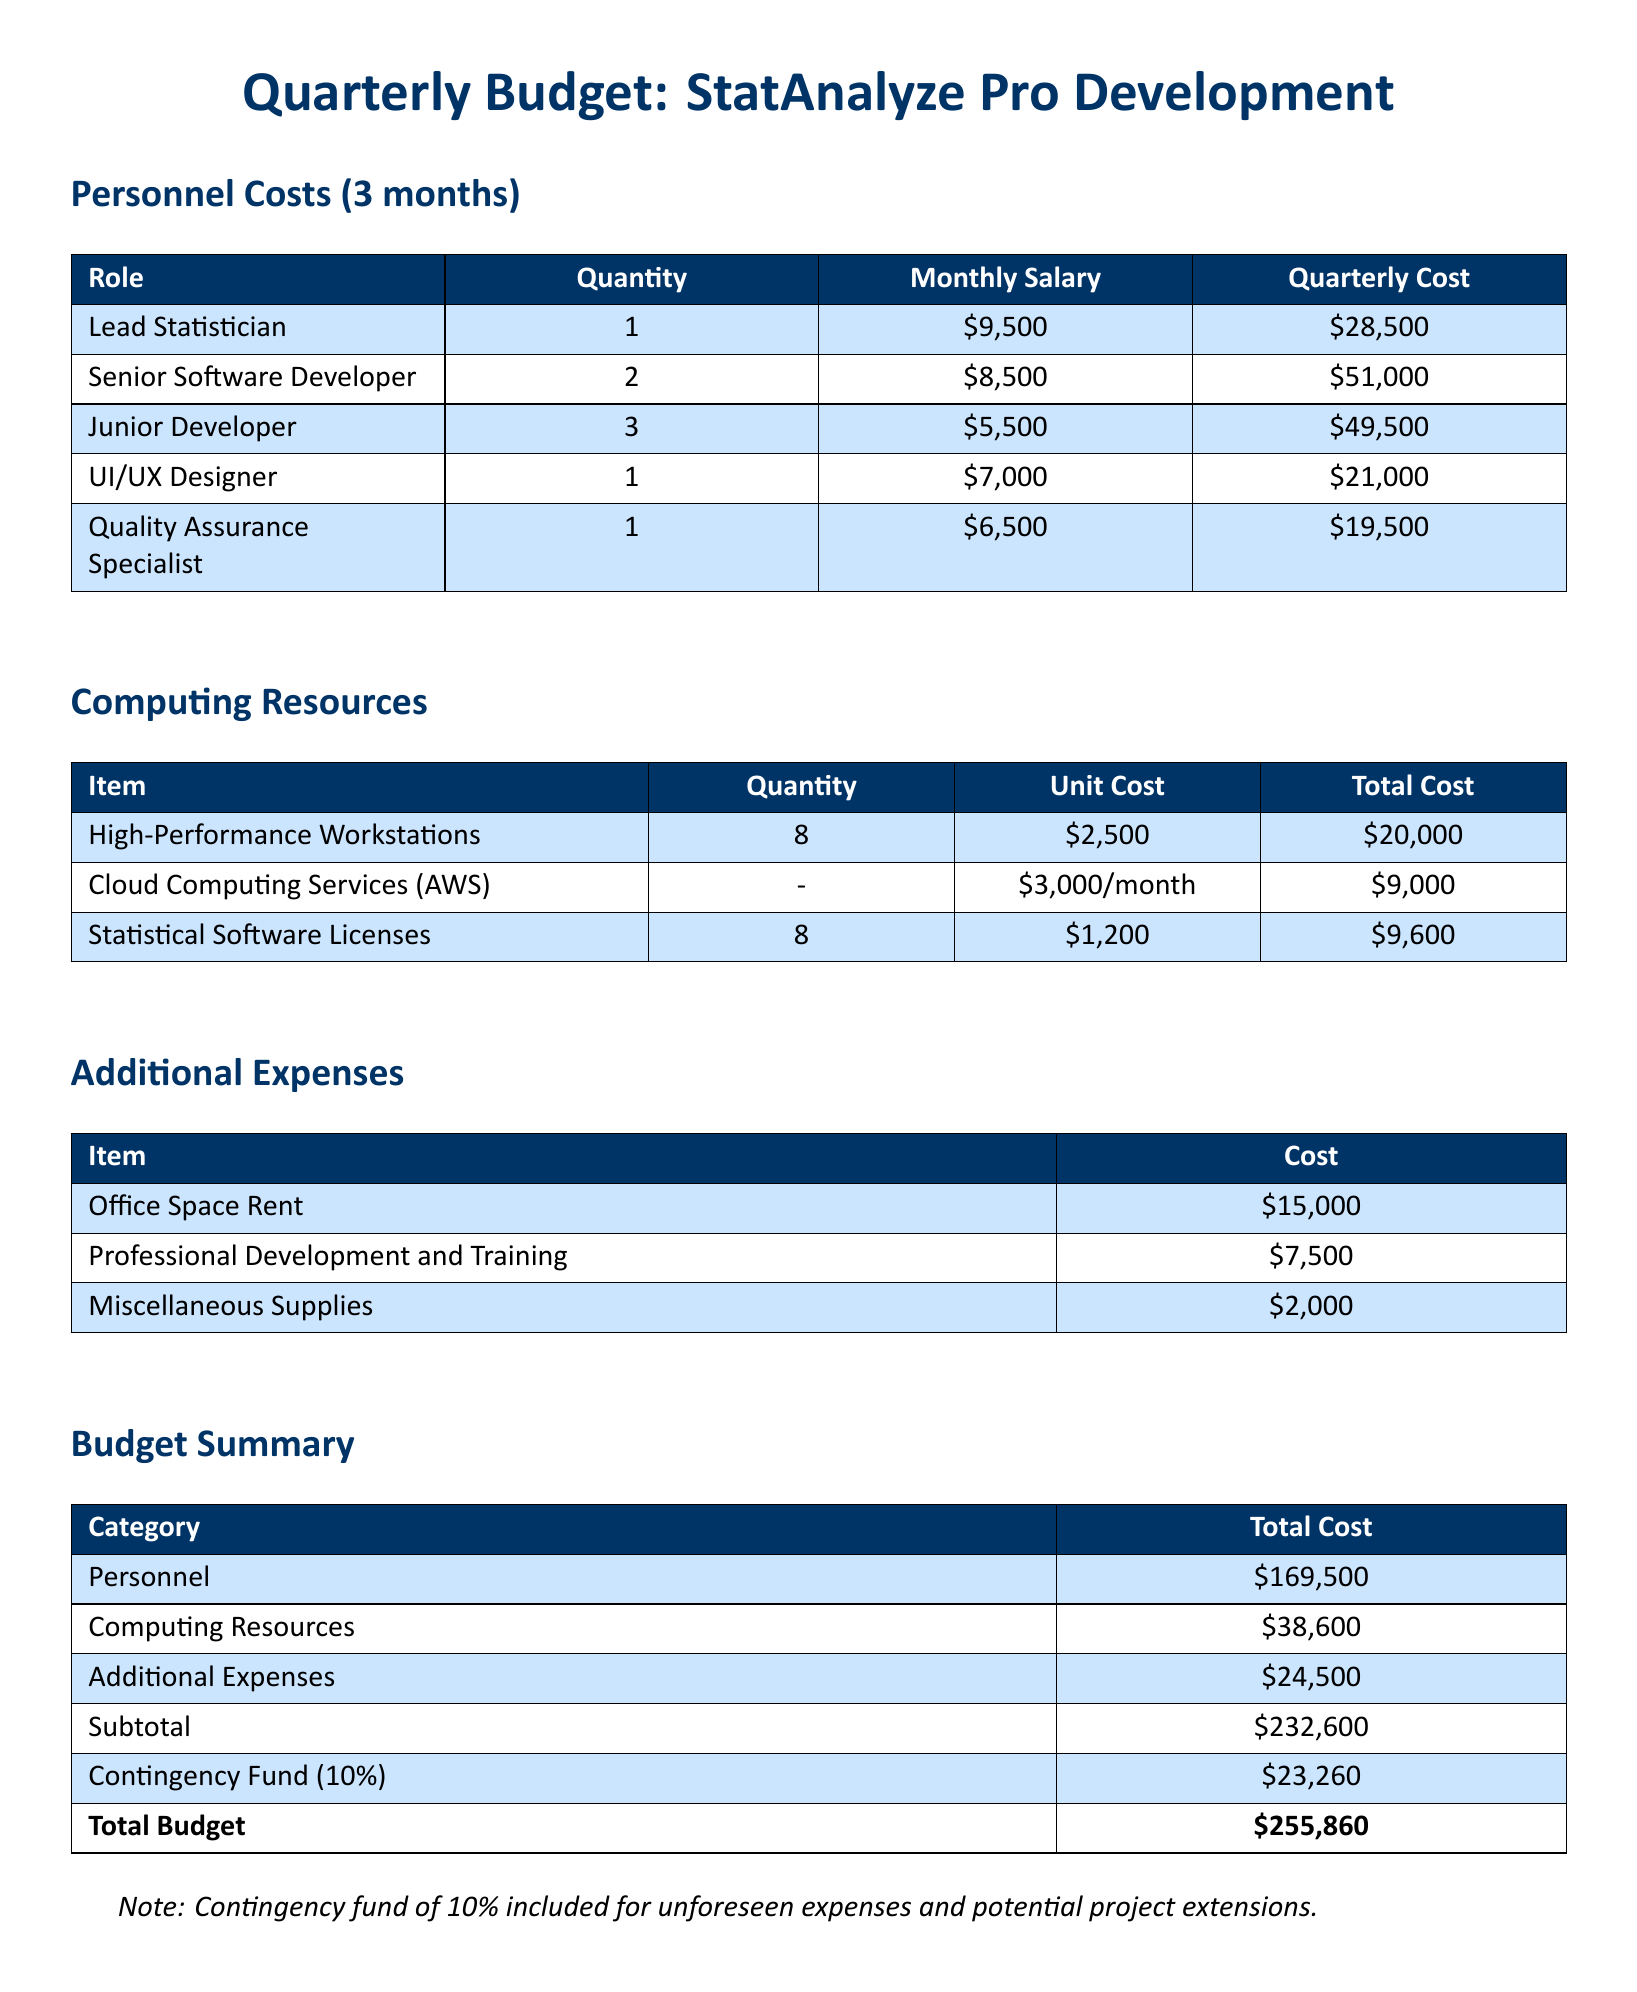What is the total personnel cost for three months? The total personnel cost is the sum of all individual roles' quarterly costs: 28500 + 51000 + 49500 + 21000 + 19500 = 169500.
Answer: 169500 How many junior developers are included in the budget? The budget specifies there are 3 junior developers listed under personnel costs.
Answer: 3 What is the unit cost for cloud computing services? The unit cost for cloud computing services is stated as 3000 per month in the computing resources section.
Answer: 3000/month What is the total budget amount? The total budget is the subtotal plus the contingency fund: 232600 + 23260 = 255860.
Answer: 255860 What is the cost for office space rent? The document states that office space rent costs 15000.
Answer: 15000 What is the monthly salary of a senior software developer? The monthly salary for a senior software developer is listed as 8500.
Answer: 8500 How many high-performance workstations are accounted for? The budget specifies there are 8 high-performance workstations listed in the computing resources section.
Answer: 8 What percentage is allocated for the contingency fund? The contingency fund allocation is specified as 10% in the budget summary.
Answer: 10% What role has the highest quarterly cost? The role with the highest quarterly cost is identified as the senior software developer with a cost of 51000.
Answer: Senior Software Developer 